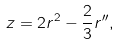<formula> <loc_0><loc_0><loc_500><loc_500>z = 2 r ^ { 2 } - \frac { 2 } { 3 } r ^ { \prime \prime } ,</formula> 